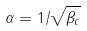Convert formula to latex. <formula><loc_0><loc_0><loc_500><loc_500>\alpha = 1 / \sqrt { \beta _ { c } }</formula> 